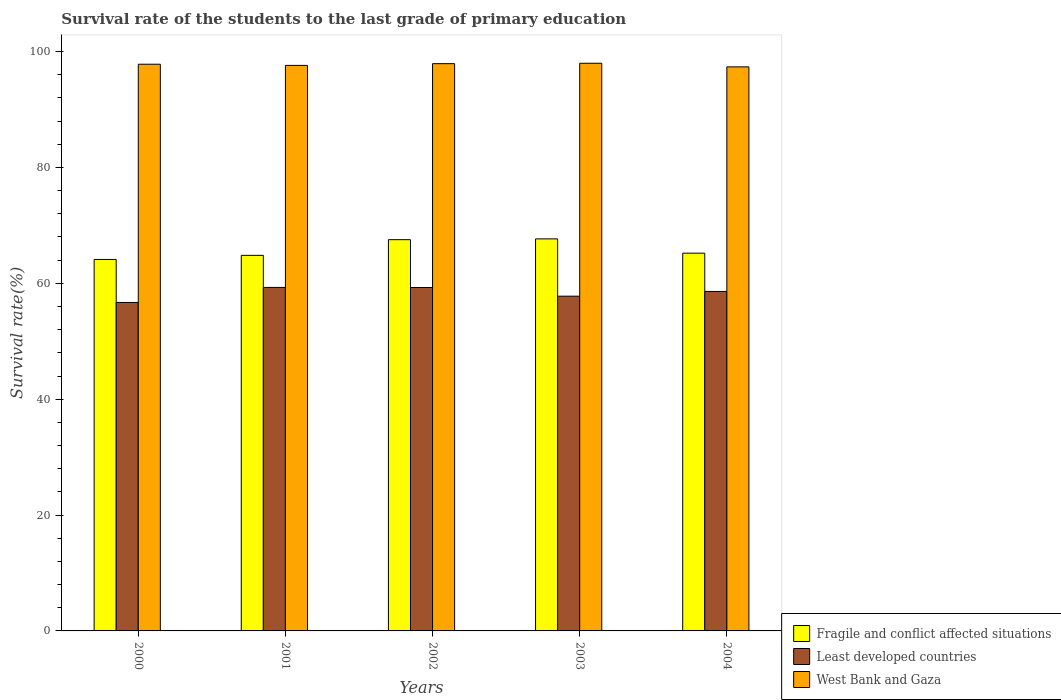How many different coloured bars are there?
Your answer should be very brief. 3. Are the number of bars per tick equal to the number of legend labels?
Offer a very short reply. Yes. Are the number of bars on each tick of the X-axis equal?
Make the answer very short. Yes. How many bars are there on the 1st tick from the left?
Make the answer very short. 3. What is the label of the 5th group of bars from the left?
Ensure brevity in your answer.  2004. What is the survival rate of the students in West Bank and Gaza in 2003?
Your answer should be compact. 97.98. Across all years, what is the maximum survival rate of the students in Fragile and conflict affected situations?
Keep it short and to the point. 67.67. Across all years, what is the minimum survival rate of the students in Fragile and conflict affected situations?
Keep it short and to the point. 64.12. What is the total survival rate of the students in Least developed countries in the graph?
Your answer should be very brief. 291.65. What is the difference between the survival rate of the students in West Bank and Gaza in 2000 and that in 2001?
Provide a succinct answer. 0.2. What is the difference between the survival rate of the students in Fragile and conflict affected situations in 2000 and the survival rate of the students in Least developed countries in 2003?
Offer a terse response. 6.34. What is the average survival rate of the students in West Bank and Gaza per year?
Your answer should be compact. 97.74. In the year 2003, what is the difference between the survival rate of the students in West Bank and Gaza and survival rate of the students in Fragile and conflict affected situations?
Keep it short and to the point. 30.32. What is the ratio of the survival rate of the students in Least developed countries in 2000 to that in 2001?
Ensure brevity in your answer.  0.96. What is the difference between the highest and the second highest survival rate of the students in Fragile and conflict affected situations?
Provide a succinct answer. 0.14. What is the difference between the highest and the lowest survival rate of the students in Fragile and conflict affected situations?
Ensure brevity in your answer.  3.55. In how many years, is the survival rate of the students in West Bank and Gaza greater than the average survival rate of the students in West Bank and Gaza taken over all years?
Offer a terse response. 3. Is the sum of the survival rate of the students in West Bank and Gaza in 2001 and 2003 greater than the maximum survival rate of the students in Least developed countries across all years?
Keep it short and to the point. Yes. What does the 1st bar from the left in 2004 represents?
Your response must be concise. Fragile and conflict affected situations. What does the 1st bar from the right in 2001 represents?
Offer a terse response. West Bank and Gaza. How many years are there in the graph?
Provide a succinct answer. 5. What is the difference between two consecutive major ticks on the Y-axis?
Provide a short and direct response. 20. Are the values on the major ticks of Y-axis written in scientific E-notation?
Offer a terse response. No. Does the graph contain any zero values?
Give a very brief answer. No. Where does the legend appear in the graph?
Keep it short and to the point. Bottom right. How many legend labels are there?
Provide a short and direct response. 3. How are the legend labels stacked?
Offer a terse response. Vertical. What is the title of the graph?
Ensure brevity in your answer.  Survival rate of the students to the last grade of primary education. Does "Rwanda" appear as one of the legend labels in the graph?
Your answer should be compact. No. What is the label or title of the X-axis?
Ensure brevity in your answer.  Years. What is the label or title of the Y-axis?
Give a very brief answer. Survival rate(%). What is the Survival rate(%) of Fragile and conflict affected situations in 2000?
Keep it short and to the point. 64.12. What is the Survival rate(%) in Least developed countries in 2000?
Your response must be concise. 56.7. What is the Survival rate(%) of West Bank and Gaza in 2000?
Offer a very short reply. 97.82. What is the Survival rate(%) in Fragile and conflict affected situations in 2001?
Offer a very short reply. 64.83. What is the Survival rate(%) in Least developed countries in 2001?
Your response must be concise. 59.29. What is the Survival rate(%) of West Bank and Gaza in 2001?
Offer a very short reply. 97.61. What is the Survival rate(%) of Fragile and conflict affected situations in 2002?
Provide a succinct answer. 67.53. What is the Survival rate(%) in Least developed countries in 2002?
Provide a succinct answer. 59.28. What is the Survival rate(%) in West Bank and Gaza in 2002?
Your answer should be very brief. 97.92. What is the Survival rate(%) in Fragile and conflict affected situations in 2003?
Your answer should be compact. 67.67. What is the Survival rate(%) in Least developed countries in 2003?
Provide a succinct answer. 57.78. What is the Survival rate(%) in West Bank and Gaza in 2003?
Your response must be concise. 97.98. What is the Survival rate(%) in Fragile and conflict affected situations in 2004?
Your answer should be very brief. 65.2. What is the Survival rate(%) in Least developed countries in 2004?
Give a very brief answer. 58.6. What is the Survival rate(%) of West Bank and Gaza in 2004?
Provide a succinct answer. 97.36. Across all years, what is the maximum Survival rate(%) in Fragile and conflict affected situations?
Offer a terse response. 67.67. Across all years, what is the maximum Survival rate(%) of Least developed countries?
Ensure brevity in your answer.  59.29. Across all years, what is the maximum Survival rate(%) in West Bank and Gaza?
Give a very brief answer. 97.98. Across all years, what is the minimum Survival rate(%) of Fragile and conflict affected situations?
Your answer should be very brief. 64.12. Across all years, what is the minimum Survival rate(%) in Least developed countries?
Your response must be concise. 56.7. Across all years, what is the minimum Survival rate(%) in West Bank and Gaza?
Provide a succinct answer. 97.36. What is the total Survival rate(%) of Fragile and conflict affected situations in the graph?
Ensure brevity in your answer.  329.35. What is the total Survival rate(%) of Least developed countries in the graph?
Offer a terse response. 291.65. What is the total Survival rate(%) of West Bank and Gaza in the graph?
Make the answer very short. 488.69. What is the difference between the Survival rate(%) in Fragile and conflict affected situations in 2000 and that in 2001?
Provide a short and direct response. -0.71. What is the difference between the Survival rate(%) of Least developed countries in 2000 and that in 2001?
Provide a short and direct response. -2.59. What is the difference between the Survival rate(%) of West Bank and Gaza in 2000 and that in 2001?
Your response must be concise. 0.2. What is the difference between the Survival rate(%) in Fragile and conflict affected situations in 2000 and that in 2002?
Keep it short and to the point. -3.41. What is the difference between the Survival rate(%) in Least developed countries in 2000 and that in 2002?
Offer a very short reply. -2.58. What is the difference between the Survival rate(%) in West Bank and Gaza in 2000 and that in 2002?
Provide a short and direct response. -0.1. What is the difference between the Survival rate(%) of Fragile and conflict affected situations in 2000 and that in 2003?
Make the answer very short. -3.55. What is the difference between the Survival rate(%) in Least developed countries in 2000 and that in 2003?
Provide a succinct answer. -1.08. What is the difference between the Survival rate(%) in West Bank and Gaza in 2000 and that in 2003?
Offer a very short reply. -0.17. What is the difference between the Survival rate(%) of Fragile and conflict affected situations in 2000 and that in 2004?
Keep it short and to the point. -1.09. What is the difference between the Survival rate(%) in Least developed countries in 2000 and that in 2004?
Keep it short and to the point. -1.9. What is the difference between the Survival rate(%) in West Bank and Gaza in 2000 and that in 2004?
Your answer should be very brief. 0.45. What is the difference between the Survival rate(%) in Fragile and conflict affected situations in 2001 and that in 2002?
Offer a very short reply. -2.7. What is the difference between the Survival rate(%) of Least developed countries in 2001 and that in 2002?
Offer a very short reply. 0.01. What is the difference between the Survival rate(%) of West Bank and Gaza in 2001 and that in 2002?
Your answer should be compact. -0.3. What is the difference between the Survival rate(%) of Fragile and conflict affected situations in 2001 and that in 2003?
Keep it short and to the point. -2.84. What is the difference between the Survival rate(%) in Least developed countries in 2001 and that in 2003?
Ensure brevity in your answer.  1.51. What is the difference between the Survival rate(%) of West Bank and Gaza in 2001 and that in 2003?
Make the answer very short. -0.37. What is the difference between the Survival rate(%) of Fragile and conflict affected situations in 2001 and that in 2004?
Provide a short and direct response. -0.38. What is the difference between the Survival rate(%) of Least developed countries in 2001 and that in 2004?
Give a very brief answer. 0.69. What is the difference between the Survival rate(%) of West Bank and Gaza in 2001 and that in 2004?
Ensure brevity in your answer.  0.25. What is the difference between the Survival rate(%) of Fragile and conflict affected situations in 2002 and that in 2003?
Provide a succinct answer. -0.14. What is the difference between the Survival rate(%) of Least developed countries in 2002 and that in 2003?
Your answer should be compact. 1.5. What is the difference between the Survival rate(%) in West Bank and Gaza in 2002 and that in 2003?
Your answer should be compact. -0.07. What is the difference between the Survival rate(%) in Fragile and conflict affected situations in 2002 and that in 2004?
Make the answer very short. 2.33. What is the difference between the Survival rate(%) in Least developed countries in 2002 and that in 2004?
Your answer should be compact. 0.68. What is the difference between the Survival rate(%) in West Bank and Gaza in 2002 and that in 2004?
Your answer should be very brief. 0.55. What is the difference between the Survival rate(%) of Fragile and conflict affected situations in 2003 and that in 2004?
Your answer should be very brief. 2.46. What is the difference between the Survival rate(%) in Least developed countries in 2003 and that in 2004?
Give a very brief answer. -0.82. What is the difference between the Survival rate(%) of West Bank and Gaza in 2003 and that in 2004?
Your answer should be compact. 0.62. What is the difference between the Survival rate(%) in Fragile and conflict affected situations in 2000 and the Survival rate(%) in Least developed countries in 2001?
Keep it short and to the point. 4.83. What is the difference between the Survival rate(%) in Fragile and conflict affected situations in 2000 and the Survival rate(%) in West Bank and Gaza in 2001?
Your answer should be compact. -33.5. What is the difference between the Survival rate(%) of Least developed countries in 2000 and the Survival rate(%) of West Bank and Gaza in 2001?
Keep it short and to the point. -40.92. What is the difference between the Survival rate(%) of Fragile and conflict affected situations in 2000 and the Survival rate(%) of Least developed countries in 2002?
Give a very brief answer. 4.84. What is the difference between the Survival rate(%) of Fragile and conflict affected situations in 2000 and the Survival rate(%) of West Bank and Gaza in 2002?
Offer a terse response. -33.8. What is the difference between the Survival rate(%) of Least developed countries in 2000 and the Survival rate(%) of West Bank and Gaza in 2002?
Provide a succinct answer. -41.22. What is the difference between the Survival rate(%) of Fragile and conflict affected situations in 2000 and the Survival rate(%) of Least developed countries in 2003?
Your answer should be compact. 6.34. What is the difference between the Survival rate(%) of Fragile and conflict affected situations in 2000 and the Survival rate(%) of West Bank and Gaza in 2003?
Provide a short and direct response. -33.87. What is the difference between the Survival rate(%) of Least developed countries in 2000 and the Survival rate(%) of West Bank and Gaza in 2003?
Keep it short and to the point. -41.29. What is the difference between the Survival rate(%) of Fragile and conflict affected situations in 2000 and the Survival rate(%) of Least developed countries in 2004?
Give a very brief answer. 5.52. What is the difference between the Survival rate(%) of Fragile and conflict affected situations in 2000 and the Survival rate(%) of West Bank and Gaza in 2004?
Ensure brevity in your answer.  -33.24. What is the difference between the Survival rate(%) in Least developed countries in 2000 and the Survival rate(%) in West Bank and Gaza in 2004?
Provide a succinct answer. -40.66. What is the difference between the Survival rate(%) in Fragile and conflict affected situations in 2001 and the Survival rate(%) in Least developed countries in 2002?
Ensure brevity in your answer.  5.55. What is the difference between the Survival rate(%) of Fragile and conflict affected situations in 2001 and the Survival rate(%) of West Bank and Gaza in 2002?
Make the answer very short. -33.09. What is the difference between the Survival rate(%) in Least developed countries in 2001 and the Survival rate(%) in West Bank and Gaza in 2002?
Make the answer very short. -38.62. What is the difference between the Survival rate(%) of Fragile and conflict affected situations in 2001 and the Survival rate(%) of Least developed countries in 2003?
Keep it short and to the point. 7.05. What is the difference between the Survival rate(%) of Fragile and conflict affected situations in 2001 and the Survival rate(%) of West Bank and Gaza in 2003?
Provide a succinct answer. -33.16. What is the difference between the Survival rate(%) in Least developed countries in 2001 and the Survival rate(%) in West Bank and Gaza in 2003?
Keep it short and to the point. -38.69. What is the difference between the Survival rate(%) in Fragile and conflict affected situations in 2001 and the Survival rate(%) in Least developed countries in 2004?
Make the answer very short. 6.23. What is the difference between the Survival rate(%) of Fragile and conflict affected situations in 2001 and the Survival rate(%) of West Bank and Gaza in 2004?
Provide a short and direct response. -32.54. What is the difference between the Survival rate(%) in Least developed countries in 2001 and the Survival rate(%) in West Bank and Gaza in 2004?
Give a very brief answer. -38.07. What is the difference between the Survival rate(%) in Fragile and conflict affected situations in 2002 and the Survival rate(%) in Least developed countries in 2003?
Provide a short and direct response. 9.75. What is the difference between the Survival rate(%) in Fragile and conflict affected situations in 2002 and the Survival rate(%) in West Bank and Gaza in 2003?
Keep it short and to the point. -30.45. What is the difference between the Survival rate(%) of Least developed countries in 2002 and the Survival rate(%) of West Bank and Gaza in 2003?
Provide a succinct answer. -38.71. What is the difference between the Survival rate(%) in Fragile and conflict affected situations in 2002 and the Survival rate(%) in Least developed countries in 2004?
Provide a succinct answer. 8.93. What is the difference between the Survival rate(%) in Fragile and conflict affected situations in 2002 and the Survival rate(%) in West Bank and Gaza in 2004?
Give a very brief answer. -29.83. What is the difference between the Survival rate(%) in Least developed countries in 2002 and the Survival rate(%) in West Bank and Gaza in 2004?
Your response must be concise. -38.08. What is the difference between the Survival rate(%) of Fragile and conflict affected situations in 2003 and the Survival rate(%) of Least developed countries in 2004?
Offer a very short reply. 9.07. What is the difference between the Survival rate(%) of Fragile and conflict affected situations in 2003 and the Survival rate(%) of West Bank and Gaza in 2004?
Your response must be concise. -29.69. What is the difference between the Survival rate(%) of Least developed countries in 2003 and the Survival rate(%) of West Bank and Gaza in 2004?
Your answer should be compact. -39.58. What is the average Survival rate(%) in Fragile and conflict affected situations per year?
Your response must be concise. 65.87. What is the average Survival rate(%) of Least developed countries per year?
Your answer should be very brief. 58.33. What is the average Survival rate(%) of West Bank and Gaza per year?
Provide a succinct answer. 97.74. In the year 2000, what is the difference between the Survival rate(%) in Fragile and conflict affected situations and Survival rate(%) in Least developed countries?
Make the answer very short. 7.42. In the year 2000, what is the difference between the Survival rate(%) of Fragile and conflict affected situations and Survival rate(%) of West Bank and Gaza?
Your answer should be compact. -33.7. In the year 2000, what is the difference between the Survival rate(%) in Least developed countries and Survival rate(%) in West Bank and Gaza?
Your answer should be compact. -41.12. In the year 2001, what is the difference between the Survival rate(%) in Fragile and conflict affected situations and Survival rate(%) in Least developed countries?
Make the answer very short. 5.54. In the year 2001, what is the difference between the Survival rate(%) in Fragile and conflict affected situations and Survival rate(%) in West Bank and Gaza?
Your answer should be compact. -32.79. In the year 2001, what is the difference between the Survival rate(%) in Least developed countries and Survival rate(%) in West Bank and Gaza?
Give a very brief answer. -38.32. In the year 2002, what is the difference between the Survival rate(%) in Fragile and conflict affected situations and Survival rate(%) in Least developed countries?
Your response must be concise. 8.25. In the year 2002, what is the difference between the Survival rate(%) in Fragile and conflict affected situations and Survival rate(%) in West Bank and Gaza?
Keep it short and to the point. -30.38. In the year 2002, what is the difference between the Survival rate(%) of Least developed countries and Survival rate(%) of West Bank and Gaza?
Provide a succinct answer. -38.64. In the year 2003, what is the difference between the Survival rate(%) of Fragile and conflict affected situations and Survival rate(%) of Least developed countries?
Ensure brevity in your answer.  9.89. In the year 2003, what is the difference between the Survival rate(%) of Fragile and conflict affected situations and Survival rate(%) of West Bank and Gaza?
Your answer should be very brief. -30.32. In the year 2003, what is the difference between the Survival rate(%) in Least developed countries and Survival rate(%) in West Bank and Gaza?
Offer a terse response. -40.2. In the year 2004, what is the difference between the Survival rate(%) in Fragile and conflict affected situations and Survival rate(%) in Least developed countries?
Provide a short and direct response. 6.61. In the year 2004, what is the difference between the Survival rate(%) in Fragile and conflict affected situations and Survival rate(%) in West Bank and Gaza?
Ensure brevity in your answer.  -32.16. In the year 2004, what is the difference between the Survival rate(%) in Least developed countries and Survival rate(%) in West Bank and Gaza?
Provide a succinct answer. -38.77. What is the ratio of the Survival rate(%) of Least developed countries in 2000 to that in 2001?
Ensure brevity in your answer.  0.96. What is the ratio of the Survival rate(%) of Fragile and conflict affected situations in 2000 to that in 2002?
Your answer should be very brief. 0.95. What is the ratio of the Survival rate(%) of Least developed countries in 2000 to that in 2002?
Keep it short and to the point. 0.96. What is the ratio of the Survival rate(%) in Fragile and conflict affected situations in 2000 to that in 2003?
Offer a very short reply. 0.95. What is the ratio of the Survival rate(%) in Least developed countries in 2000 to that in 2003?
Provide a succinct answer. 0.98. What is the ratio of the Survival rate(%) of West Bank and Gaza in 2000 to that in 2003?
Your response must be concise. 1. What is the ratio of the Survival rate(%) of Fragile and conflict affected situations in 2000 to that in 2004?
Ensure brevity in your answer.  0.98. What is the ratio of the Survival rate(%) of Least developed countries in 2000 to that in 2004?
Your answer should be compact. 0.97. What is the ratio of the Survival rate(%) of Fragile and conflict affected situations in 2001 to that in 2002?
Your answer should be very brief. 0.96. What is the ratio of the Survival rate(%) in Least developed countries in 2001 to that in 2002?
Offer a very short reply. 1. What is the ratio of the Survival rate(%) in West Bank and Gaza in 2001 to that in 2002?
Provide a short and direct response. 1. What is the ratio of the Survival rate(%) in Fragile and conflict affected situations in 2001 to that in 2003?
Ensure brevity in your answer.  0.96. What is the ratio of the Survival rate(%) in Least developed countries in 2001 to that in 2003?
Ensure brevity in your answer.  1.03. What is the ratio of the Survival rate(%) in Fragile and conflict affected situations in 2001 to that in 2004?
Provide a succinct answer. 0.99. What is the ratio of the Survival rate(%) of Least developed countries in 2001 to that in 2004?
Keep it short and to the point. 1.01. What is the ratio of the Survival rate(%) in Fragile and conflict affected situations in 2002 to that in 2003?
Make the answer very short. 1. What is the ratio of the Survival rate(%) of Least developed countries in 2002 to that in 2003?
Give a very brief answer. 1.03. What is the ratio of the Survival rate(%) of West Bank and Gaza in 2002 to that in 2003?
Provide a succinct answer. 1. What is the ratio of the Survival rate(%) in Fragile and conflict affected situations in 2002 to that in 2004?
Provide a succinct answer. 1.04. What is the ratio of the Survival rate(%) in Least developed countries in 2002 to that in 2004?
Keep it short and to the point. 1.01. What is the ratio of the Survival rate(%) in Fragile and conflict affected situations in 2003 to that in 2004?
Offer a very short reply. 1.04. What is the ratio of the Survival rate(%) of Least developed countries in 2003 to that in 2004?
Give a very brief answer. 0.99. What is the ratio of the Survival rate(%) in West Bank and Gaza in 2003 to that in 2004?
Your answer should be very brief. 1.01. What is the difference between the highest and the second highest Survival rate(%) of Fragile and conflict affected situations?
Provide a succinct answer. 0.14. What is the difference between the highest and the second highest Survival rate(%) of Least developed countries?
Your answer should be compact. 0.01. What is the difference between the highest and the second highest Survival rate(%) in West Bank and Gaza?
Keep it short and to the point. 0.07. What is the difference between the highest and the lowest Survival rate(%) in Fragile and conflict affected situations?
Give a very brief answer. 3.55. What is the difference between the highest and the lowest Survival rate(%) of Least developed countries?
Your answer should be compact. 2.59. What is the difference between the highest and the lowest Survival rate(%) of West Bank and Gaza?
Provide a short and direct response. 0.62. 